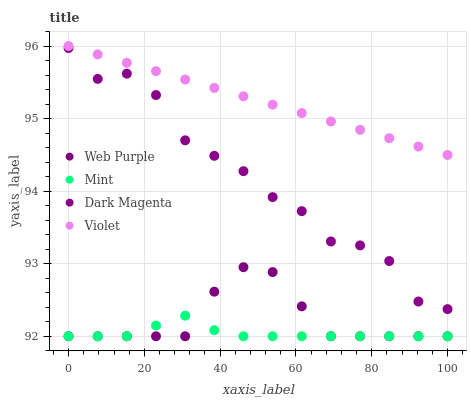Does Mint have the minimum area under the curve?
Answer yes or no. Yes. Does Violet have the maximum area under the curve?
Answer yes or no. Yes. Does Dark Magenta have the minimum area under the curve?
Answer yes or no. No. Does Dark Magenta have the maximum area under the curve?
Answer yes or no. No. Is Violet the smoothest?
Answer yes or no. Yes. Is Dark Magenta the roughest?
Answer yes or no. Yes. Is Mint the smoothest?
Answer yes or no. No. Is Mint the roughest?
Answer yes or no. No. Does Web Purple have the lowest value?
Answer yes or no. Yes. Does Dark Magenta have the lowest value?
Answer yes or no. No. Does Violet have the highest value?
Answer yes or no. Yes. Does Dark Magenta have the highest value?
Answer yes or no. No. Is Mint less than Dark Magenta?
Answer yes or no. Yes. Is Violet greater than Web Purple?
Answer yes or no. Yes. Does Mint intersect Web Purple?
Answer yes or no. Yes. Is Mint less than Web Purple?
Answer yes or no. No. Is Mint greater than Web Purple?
Answer yes or no. No. Does Mint intersect Dark Magenta?
Answer yes or no. No. 